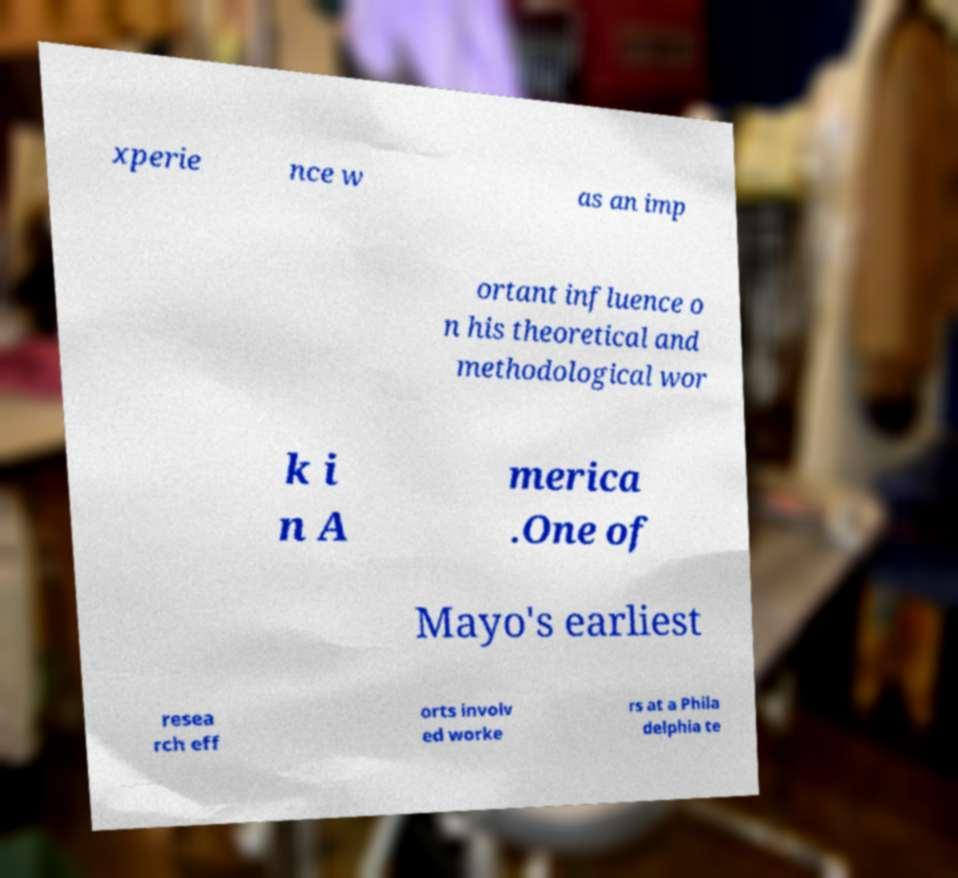Could you assist in decoding the text presented in this image and type it out clearly? xperie nce w as an imp ortant influence o n his theoretical and methodological wor k i n A merica .One of Mayo's earliest resea rch eff orts involv ed worke rs at a Phila delphia te 